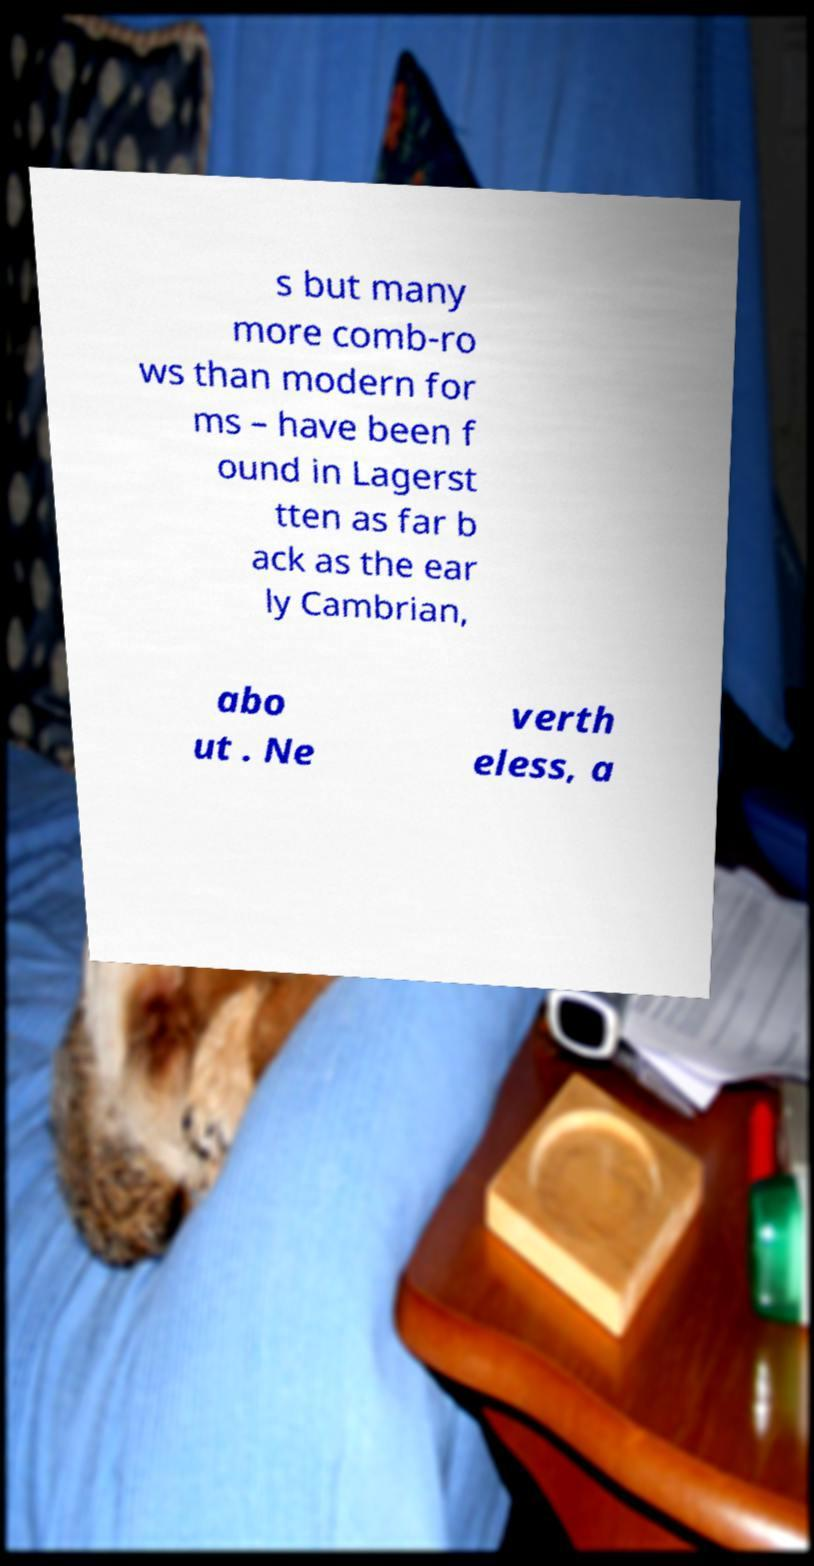Can you accurately transcribe the text from the provided image for me? s but many more comb-ro ws than modern for ms – have been f ound in Lagerst tten as far b ack as the ear ly Cambrian, abo ut . Ne verth eless, a 